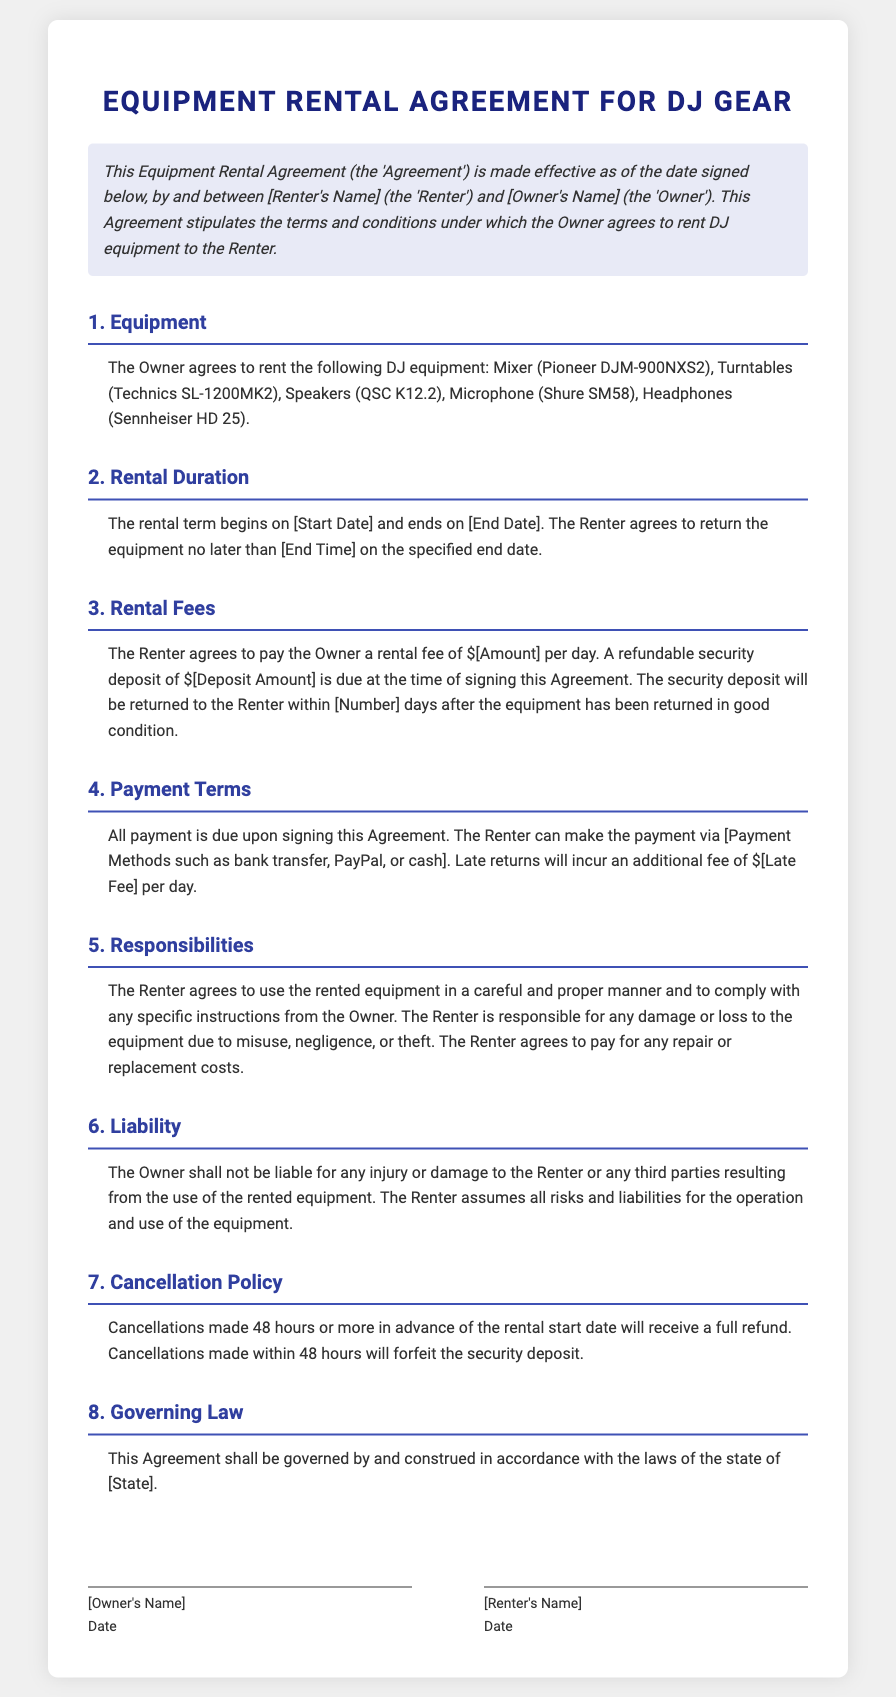What is the name of the mixer? The document lists the equipment, and the mixer is identified as the Pioneer DJM-900NXS2.
Answer: Pioneer DJM-900NXS2 What is the rental fee per day? The rental fee amount is specified directly in the document under the Rental Fees section.
Answer: $[Amount] What is the refundable security deposit? The document specifies that a refundable security deposit is due at signing, which is outlined in the Rental Fees section.
Answer: $[Deposit Amount] What is the start date for rental? The contract indicates that the rental term begins on a specified date represented as [Start Date].
Answer: [Start Date] What happens if the equipment is returned late? The late return fee is detailed in the Payment Terms section, indicating additional costs for delays.
Answer: $[Late Fee] How many days after returning does the deposit get refunded? The document mentions a time frame for the return of the security deposit after equipment return.
Answer: [Number] days What must the Renter ensure regarding the equipment? Responsibilities of the Renter include careful usage and compliance with provided instructions from the Owner.
Answer: Careful and proper manner What is the cancellation policy for a refund? The policy for cancellation refunds is specified, indicating different conditions for advance cancellation.
Answer: 48 hours What law governs this Agreement? The governing jurisdiction for the Agreement is outlined in a specific section of the document.
Answer: [State] What type of injuries is the Owner liable for? The Liability section clarifies the Owner's non-liability regarding injuries or damages.
Answer: None 